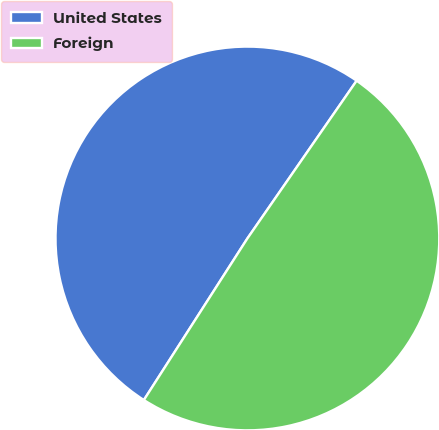<chart> <loc_0><loc_0><loc_500><loc_500><pie_chart><fcel>United States<fcel>Foreign<nl><fcel>50.57%<fcel>49.43%<nl></chart> 